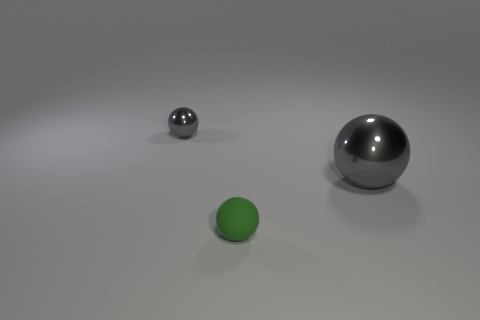What number of shiny things are behind the large ball and in front of the small metal sphere? In the image, there are no shiny objects located behind the large ball and in front of the small metal sphere. The space between these two spheres is empty. 